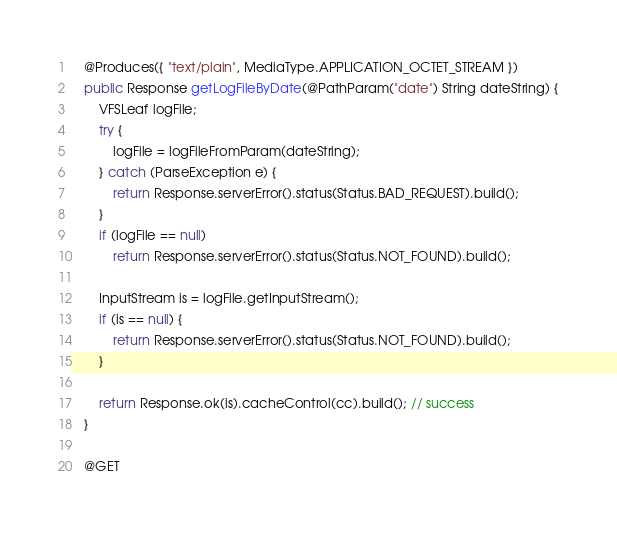Convert code to text. <code><loc_0><loc_0><loc_500><loc_500><_Java_>	@Produces({ "text/plain", MediaType.APPLICATION_OCTET_STREAM })
	public Response getLogFileByDate(@PathParam("date") String dateString) {
		VFSLeaf logFile;
		try {
			logFile = logFileFromParam(dateString);
		} catch (ParseException e) {
			return Response.serverError().status(Status.BAD_REQUEST).build();
		}
		if (logFile == null)
			return Response.serverError().status(Status.NOT_FOUND).build();

		InputStream is = logFile.getInputStream();
		if (is == null) {
			return Response.serverError().status(Status.NOT_FOUND).build();
		}

		return Response.ok(is).cacheControl(cc).build(); // success
	}
	
	@GET</code> 